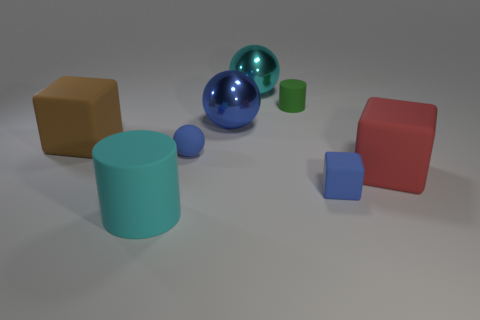There is a large brown thing; are there any big rubber cubes behind it?
Provide a succinct answer. No. Are there the same number of cylinders to the right of the big cylinder and metal things?
Offer a terse response. No. There is another rubber thing that is the same shape as the small green thing; what size is it?
Offer a very short reply. Large. Do the big blue shiny thing and the blue matte thing that is behind the large red matte cube have the same shape?
Keep it short and to the point. Yes. What is the size of the cube behind the big cube in front of the big brown rubber block?
Give a very brief answer. Large. Is the number of brown objects that are to the right of the tiny blue ball the same as the number of big matte things in front of the brown rubber block?
Provide a succinct answer. No. There is another large object that is the same shape as the big brown matte thing; what is its color?
Your answer should be compact. Red. What number of small matte things have the same color as the matte ball?
Keep it short and to the point. 1. There is a big thing behind the large blue metallic object; is it the same shape as the cyan matte object?
Ensure brevity in your answer.  No. There is a shiny thing to the left of the cyan metal ball that is behind the cyan thing that is in front of the large blue sphere; what shape is it?
Offer a terse response. Sphere. 